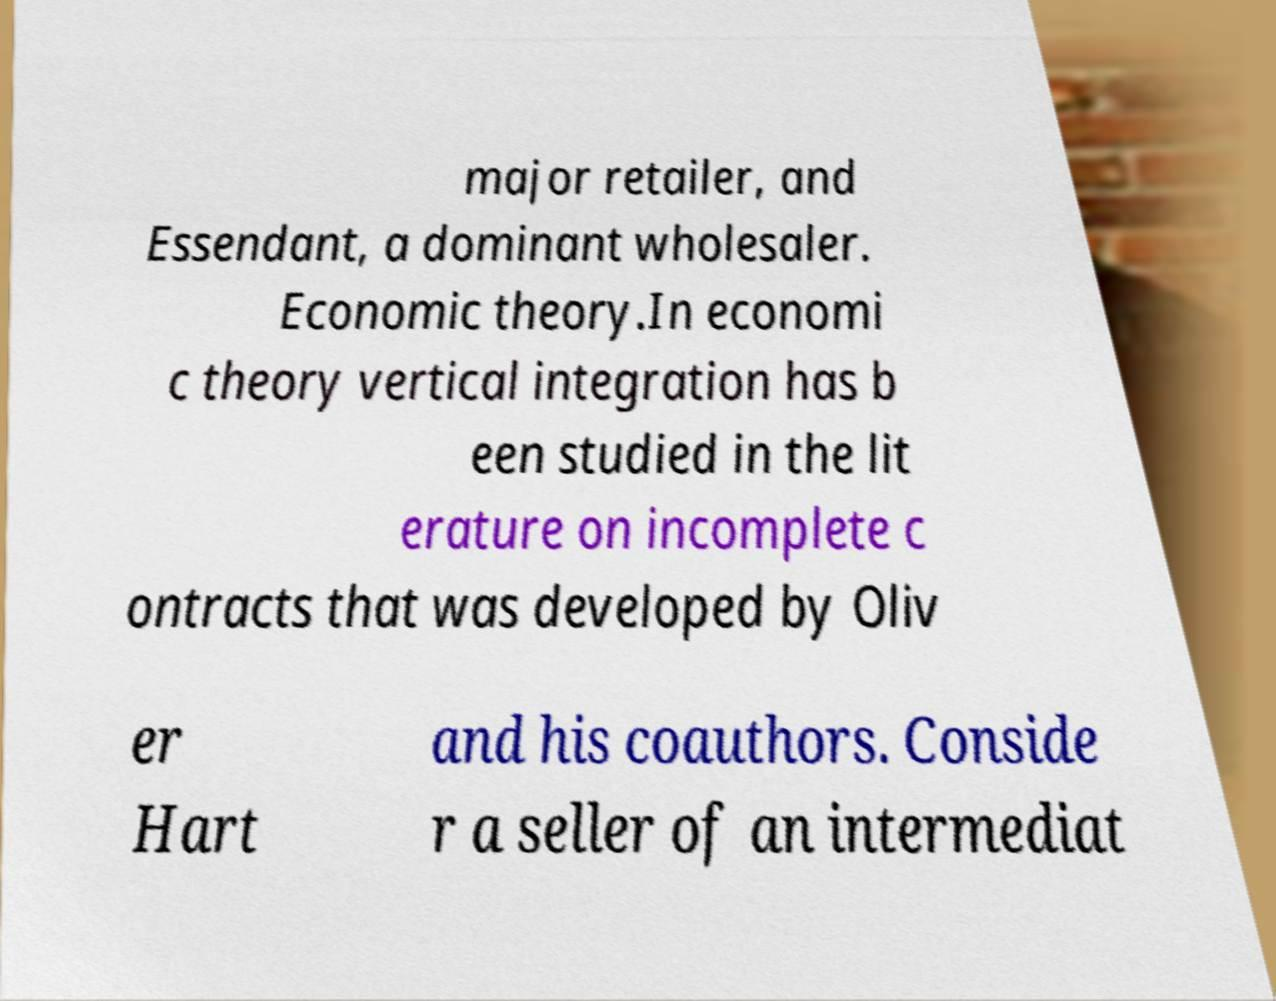For documentation purposes, I need the text within this image transcribed. Could you provide that? major retailer, and Essendant, a dominant wholesaler. Economic theory.In economi c theory vertical integration has b een studied in the lit erature on incomplete c ontracts that was developed by Oliv er Hart and his coauthors. Conside r a seller of an intermediat 